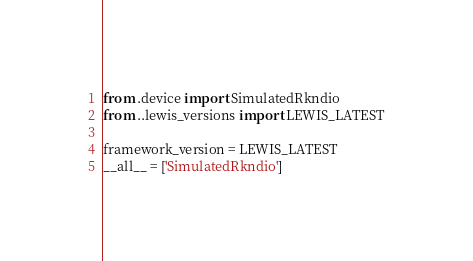<code> <loc_0><loc_0><loc_500><loc_500><_Python_>from .device import SimulatedRkndio
from ..lewis_versions import LEWIS_LATEST

framework_version = LEWIS_LATEST
__all__ = ['SimulatedRkndio']
</code> 